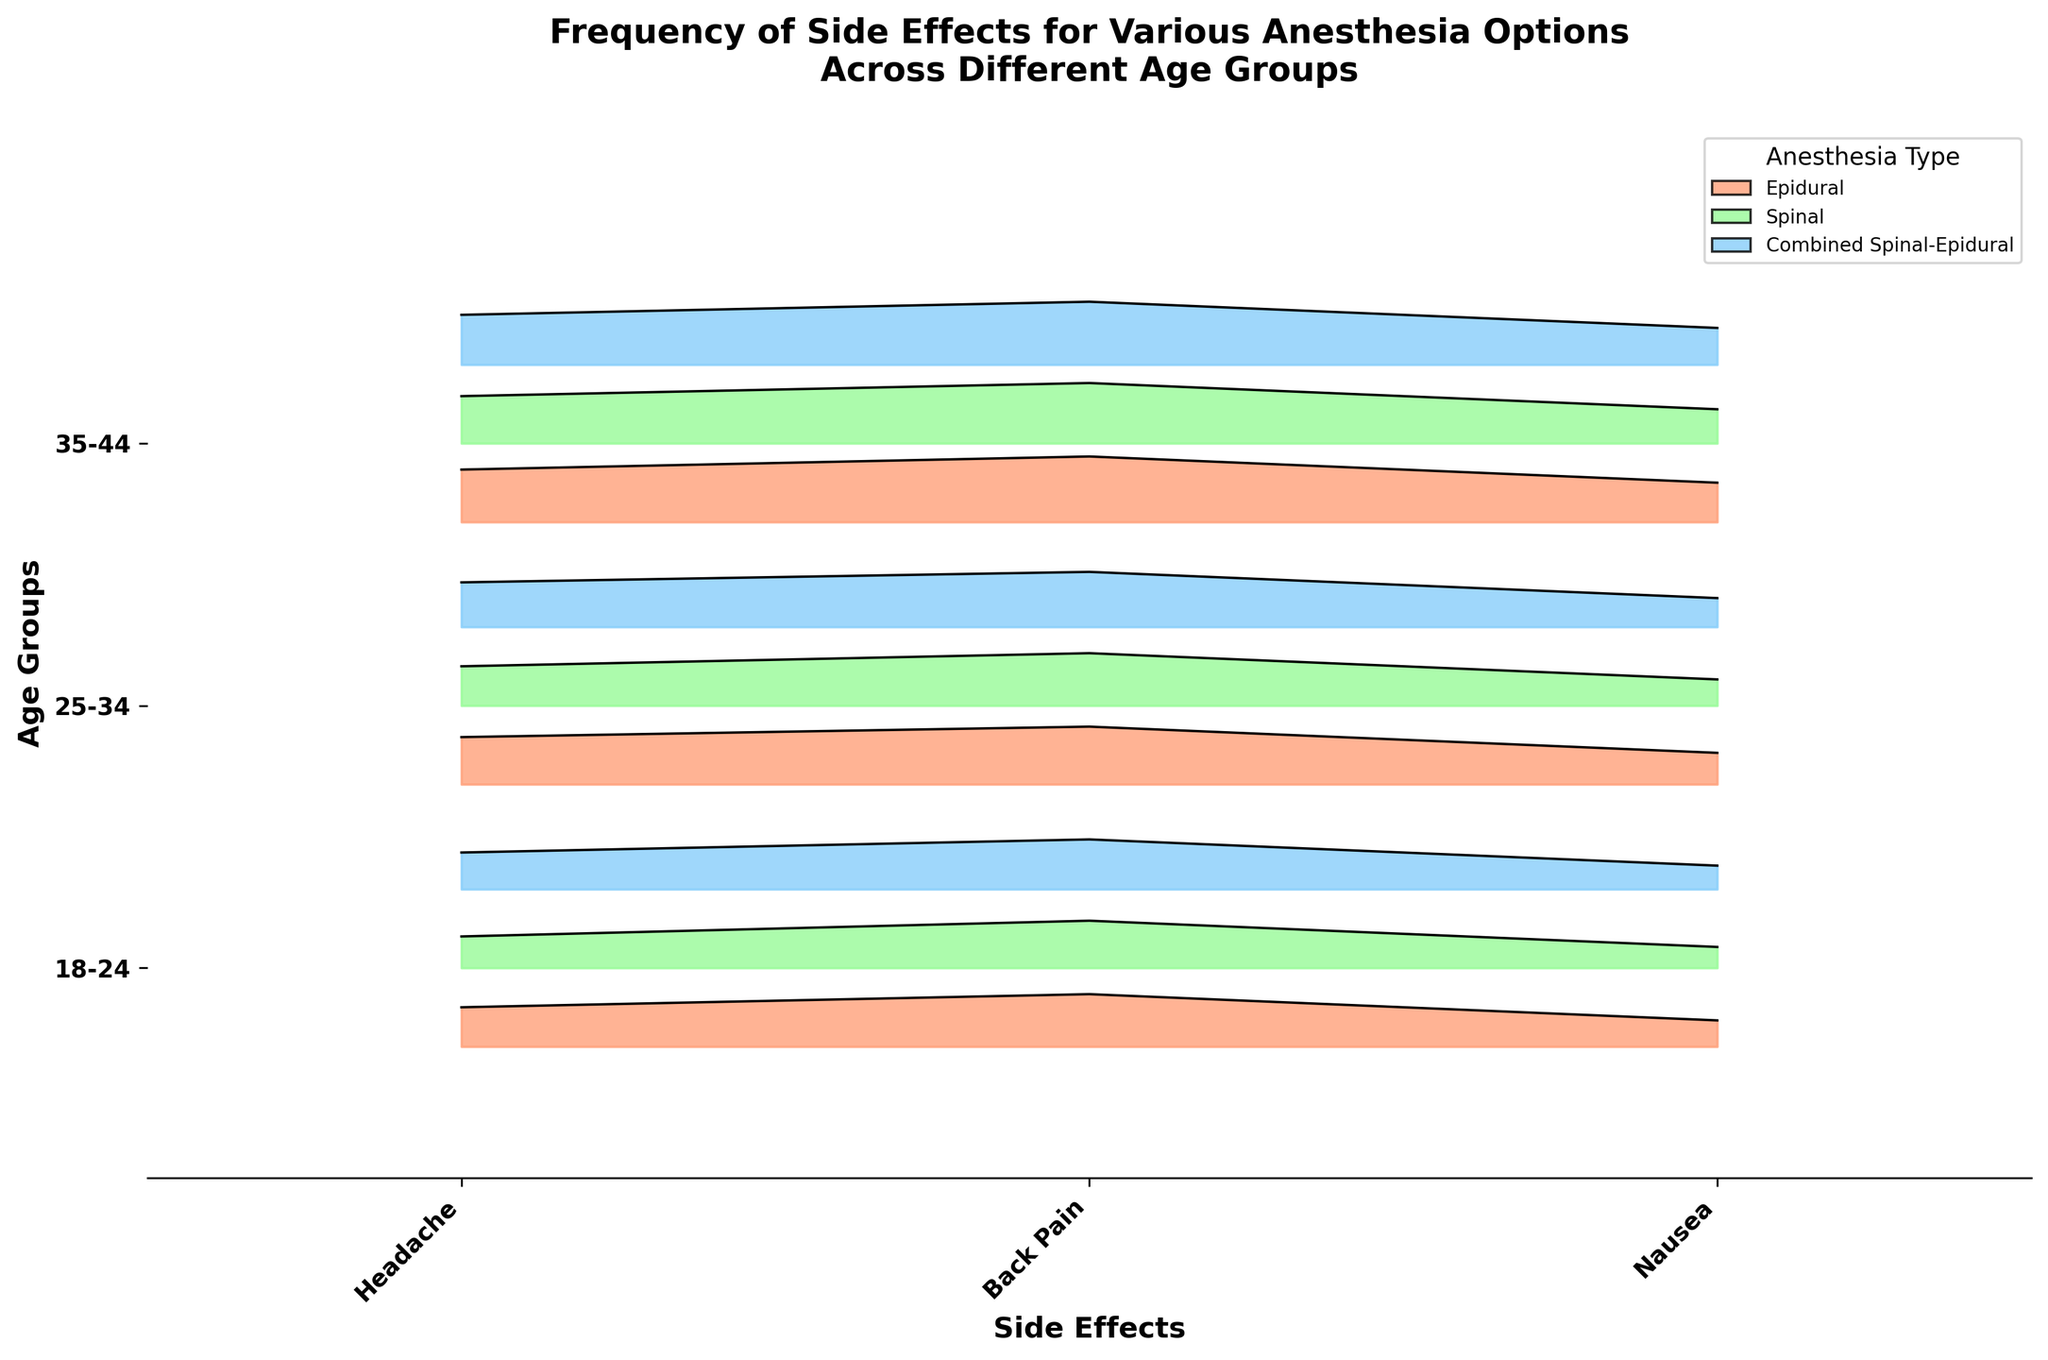What is the title of the plot? The title is typically located at the top center of the plot. By looking there, we see the given title.
Answer: Frequency of Side Effects for Various Anesthesia Options Across Different Age Groups What are the age groups considered in this plot? The age groups are indicated on the y-axis with corresponding labels. By checking the labels on the y-axis, we can see which age groups are included.
Answer: 18-24, 25-34, 35-44 Which anesthesia type has the highest frequency of back pain for the age group 35-44? To determine this, we look at the ridgeline plots for the 35-44 age group, focusing on the section labeled "Back Pain". We compare the heights of the plots for each anesthesia type.
Answer: Epidural What are the side effects measured in this plot? The side effects are labeled on the x-axis of the plot. By reading these labels, we can identify the side effects included.
Answer: Headache, Back Pain, Nausea Which anesthesia type for the age group 25-34 has the lowest frequency of nausea? Look at the ridgeline plots for the 25-34 age group, specifically at the section labeled "Nausea". Compare the heights of the plots for each anesthesia type to find the lowest frequency.
Answer: Spinal How does the frequency of headaches for the age group 18-24 compare between Epidural and Combined Spinal-Epidural? For the 18-24 age group, check the ridgeline plots labeled "Headache" for both Epidural and Combined Spinal-Epidural and compare their heights.
Answer: Combined Spinal-Epidural is lower than Epidural What is the most common side effect for the age group 25-34 using Spinal anesthesia? For the age group 25-34, focus on the ridgeline plots for the Spinal anesthesia type and compare the frequencies of different side effects.
Answer: Back Pain Are there any anesthesia types that have a higher frequency of side effects for the 18-24 age group compared to the 35-44 age group? Compare the ridgeline plots for the 18-24 and 35-44 age groups across all side effects and anesthesia types to see if any in 18-24 have higher frequencies.
Answer: No, frequencies in 35-44 are generally higher Is the distribution of side effects across different anesthesia types consistent for all age groups? Observe the pattern of frequencies for each side effect and anesthesia type across all age groups to check for consistency.
Answer: Yes, similar trends are seen 